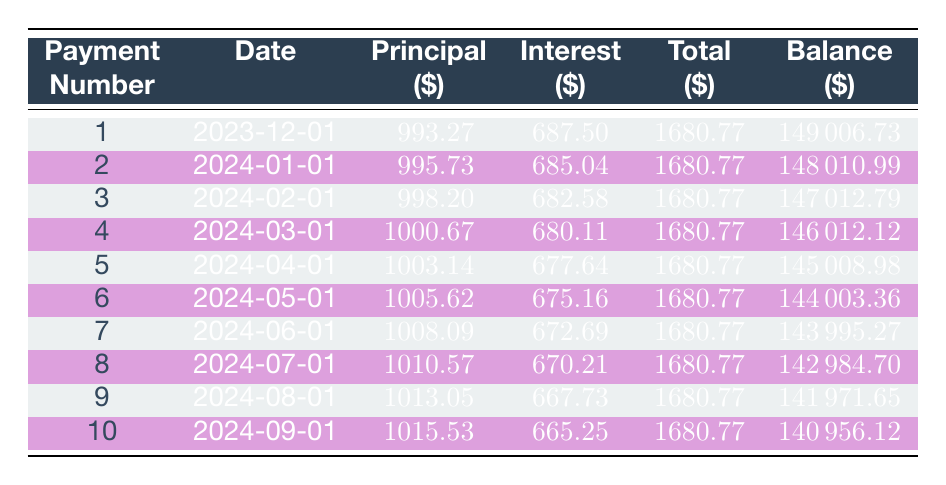What is the total amount of the loan taken by Craft Brew Innovations? The table indicates that the loan amount is listed in the loan details section. It states that the loan amount is 150000.
Answer: 150000 When is the first payment due? The first payment is stated in the loan details, which specifies the first payment date as December 1, 2023.
Answer: December 1, 2023 How much was paid toward the principal in the first payment? From the first row of the payment schedule, the principal payment for the first payment is 993.27.
Answer: 993.27 Is the interest payment for the second month higher or lower than the first month? The interest payment for the first month is 687.50 (from payment number 1) and for the second month is 685.04 (from payment number 2). Comparing these two values shows that the interest payment for the second month is lower.
Answer: Lower What is the total amount paid towards the loan principal after the first three payments? The principal payments for the first three payments are 993.27, 995.73, and 998.20. Summing these amounts gives: 993.27 + 995.73 + 998.20 = 2987.20.
Answer: 2987.20 What is the remaining balance after the fifth payment? The remaining balance is listed in the payment schedule. After the fifth payment (which is on April 1, 2024), the remaining balance is 145008.98.
Answer: 145008.98 What is the average interest payment for the first ten payments? The interest payments for the first ten payments are as follows: 687.50, 685.04, 682.58, 680.11, 677.64, 675.16, 672.69, 670.21, 667.73, and 665.25. Summing these gives 6814.66, and dividing by 10 (the number of payments) results in an average of 681.47.
Answer: 681.47 How many more payments are needed after the first 10 payments are made? The total loan term is 10 years with monthly payments, which results in a total of 120 payments. Since 10 payments have been made, the remaining payments are 120 - 10 = 110.
Answer: 110 Was the total payment for the 7th month greater than or equal to the total payment for the 8th month? The total payments for the seventh payment is 1680.77 and for the eighth payment is also 1680.77. Since both amounts are equal, the answer is yes.
Answer: Yes What is the difference in total payments between the 4th and 5th payments? Both the 4th and 5th payments are equal at 1680.77, so the difference is 1680.77 - 1680.77 = 0.
Answer: 0 